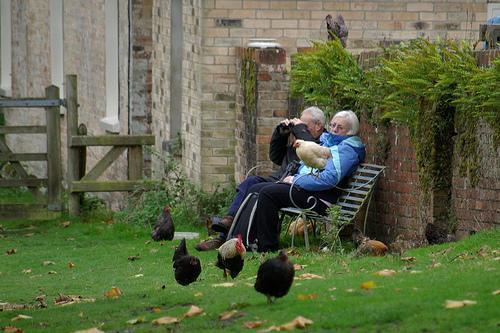How many chickens are in the photo?
Give a very brief answer. 7. 